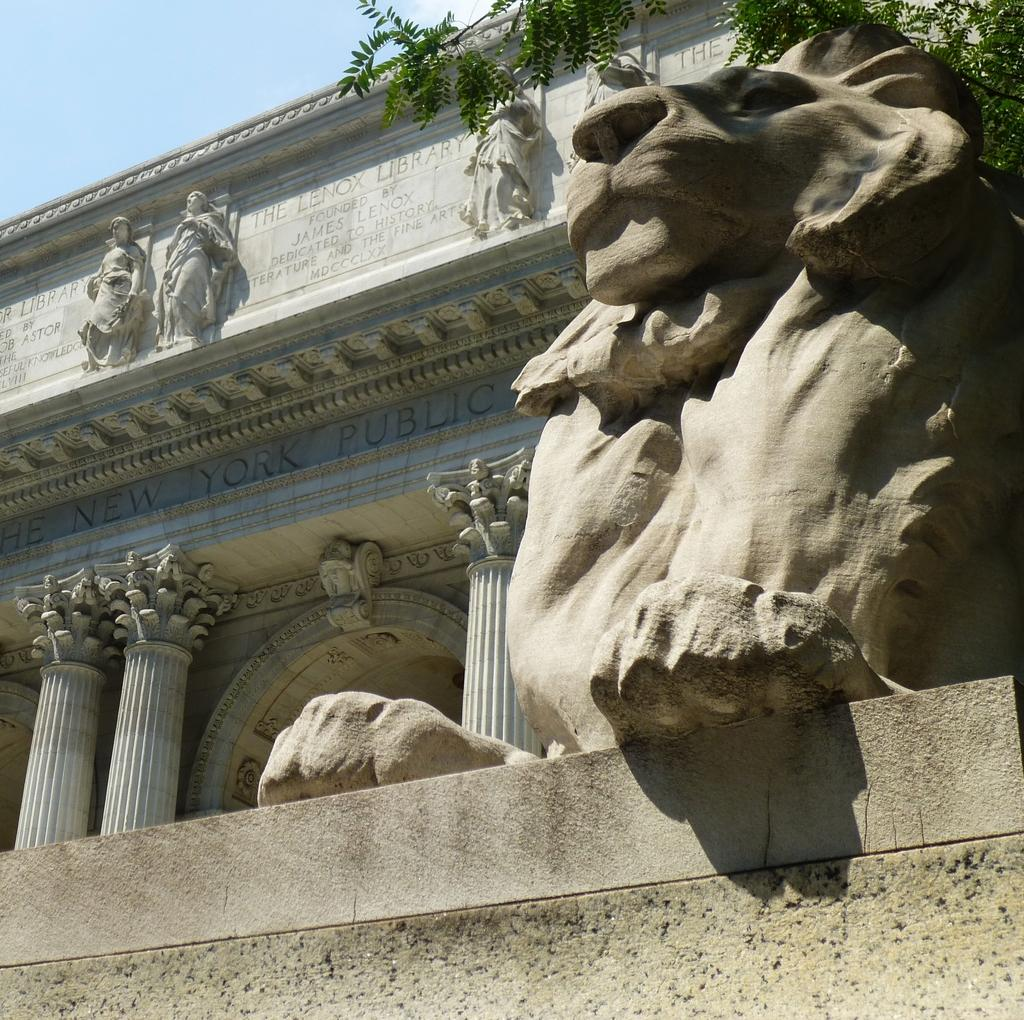What type of objects can be seen in the image? There are statues in the image. What structure is present in the image? There is a building in the image. What type of plant is visible in the image? There is a tree in the image. What is visible in the background of the image? The sky is visible in the image. What type of butter can be seen melting on the statues in the image? There is no butter present in the image; it features statues, a building, a tree, and the sky. What is the aftermath of the event depicted in the image? There is no event depicted in the image, as it only shows statues, a building, a tree, and the sky. 